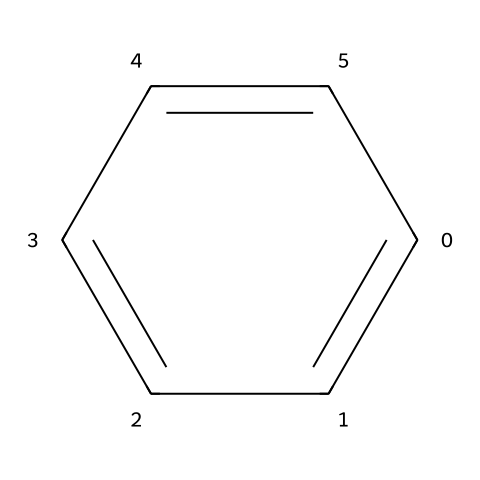What is the name of this chemical? The structure provided corresponds to benzene, a well-known aromatic compound. The arrangement of carbon atoms in a cyclic manner with alternating double bonds is characteristic of benzene.
Answer: benzene How many carbon atoms are present? The SMILES representation indicates that there are six carbon atoms in the structure of benzene, represented as 'c' in the notation.
Answer: six What is the bond type between the carbon atoms? The structure of benzene features alternating double and single bonds between the carbon atoms, which is typical of aromatic compounds due to resonance stabilization.
Answer: aromatic How many hydrogen atoms are attached to the benzene ring? Benzene has six hydrogen atoms, as each carbon atom forms one bond with a hydrogen atom in the structure. This is derived from the fact that each carbon atom forms four bonds total, and in benzene, they are satisfied by one hydrogen each.
Answer: six What type of molecular hybridization do the carbon atoms exhibit? The carbon atoms in benzene are sp2 hybridized, as each carbon atom is involved in one double bond and one single bond with hydrogen, allowing for a planar structure.
Answer: sp2 What property allows benzene to be used as an air freshener in vintage cars? Benzene's pleasant aromatic scent makes it favorable for use in fragrance applications, such as air fresheners. The unique structure contributes to its alluring olfactory properties.
Answer: pleasant aroma Why is benzene classified as an aromatic compound? Benzene is classified as an aromatic compound due to its cyclic structure, delocalized pi electrons, and adherence to Huckel's rule, which states that it must have (4n + 2) pi electrons (in this case, 6).
Answer: cyclic structure 